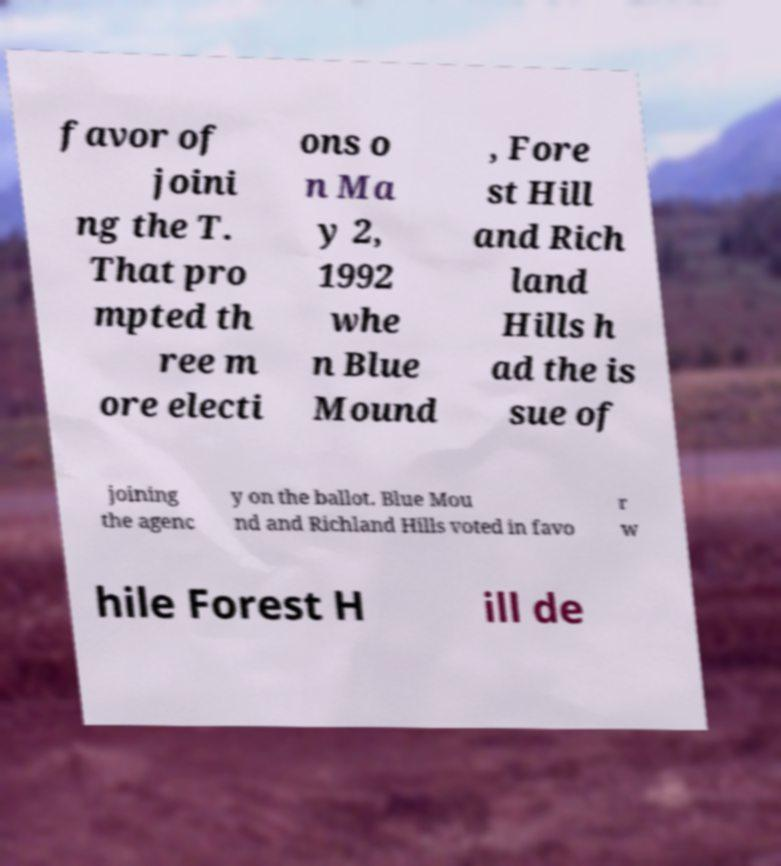Please identify and transcribe the text found in this image. favor of joini ng the T. That pro mpted th ree m ore electi ons o n Ma y 2, 1992 whe n Blue Mound , Fore st Hill and Rich land Hills h ad the is sue of joining the agenc y on the ballot. Blue Mou nd and Richland Hills voted in favo r w hile Forest H ill de 